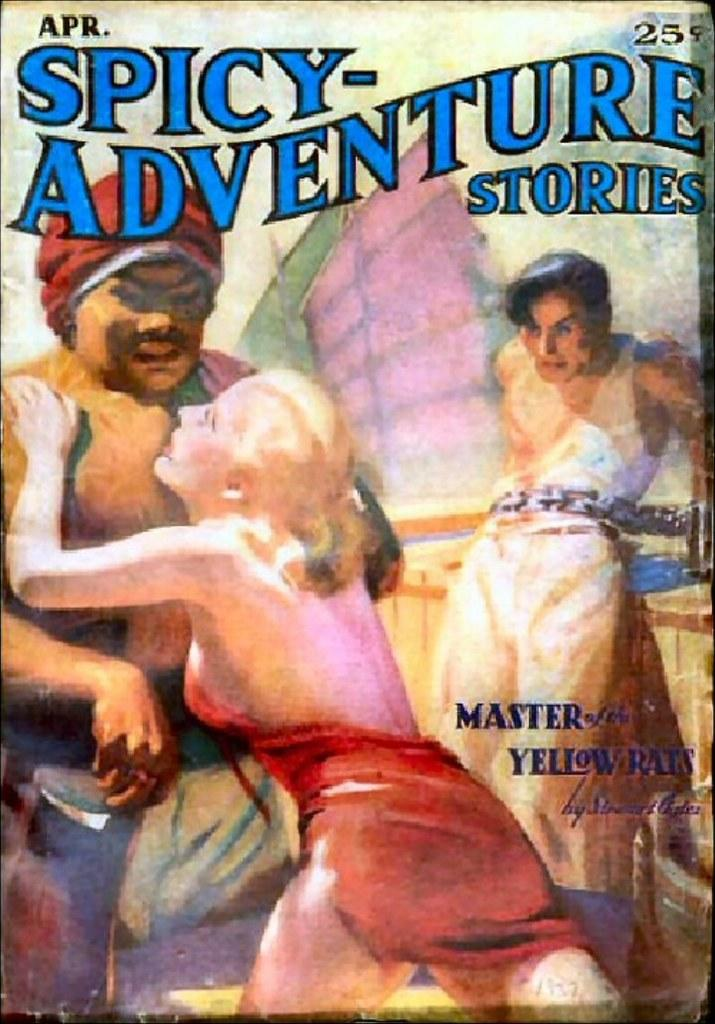What is the main subject in the image? There is a poster in the image. What type of mint can be seen growing on the poster in the image? There is no mint visible on the poster in the image. Can you describe how the poster is stretching across the wall in the image? The poster is not stretching across the wall in the image; it is a static image of a poster. 